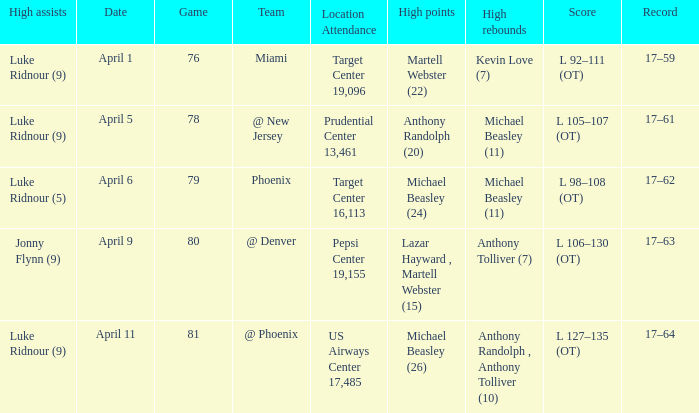I'm looking to parse the entire table for insights. Could you assist me with that? {'header': ['High assists', 'Date', 'Game', 'Team', 'Location Attendance', 'High points', 'High rebounds', 'Score', 'Record'], 'rows': [['Luke Ridnour (9)', 'April 1', '76', 'Miami', 'Target Center 19,096', 'Martell Webster (22)', 'Kevin Love (7)', 'L 92–111 (OT)', '17–59'], ['Luke Ridnour (9)', 'April 5', '78', '@ New Jersey', 'Prudential Center 13,461', 'Anthony Randolph (20)', 'Michael Beasley (11)', 'L 105–107 (OT)', '17–61'], ['Luke Ridnour (5)', 'April 6', '79', 'Phoenix', 'Target Center 16,113', 'Michael Beasley (24)', 'Michael Beasley (11)', 'L 98–108 (OT)', '17–62'], ['Jonny Flynn (9)', 'April 9', '80', '@ Denver', 'Pepsi Center 19,155', 'Lazar Hayward , Martell Webster (15)', 'Anthony Tolliver (7)', 'L 106–130 (OT)', '17–63'], ['Luke Ridnour (9)', 'April 11', '81', '@ Phoenix', 'US Airways Center 17,485', 'Michael Beasley (26)', 'Anthony Randolph , Anthony Tolliver (10)', 'L 127–135 (OT)', '17–64']]} In how many different games did Luke Ridnour (5) did the most high assists? 1.0. 